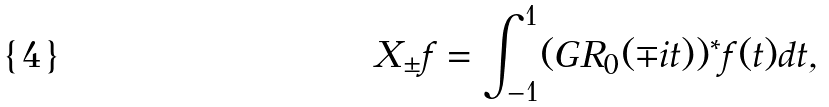Convert formula to latex. <formula><loc_0><loc_0><loc_500><loc_500>X _ { \pm } f = \int _ { - 1 } ^ { 1 } ( G R _ { 0 } ( \mp i t ) ) ^ { * } f ( t ) d t ,</formula> 